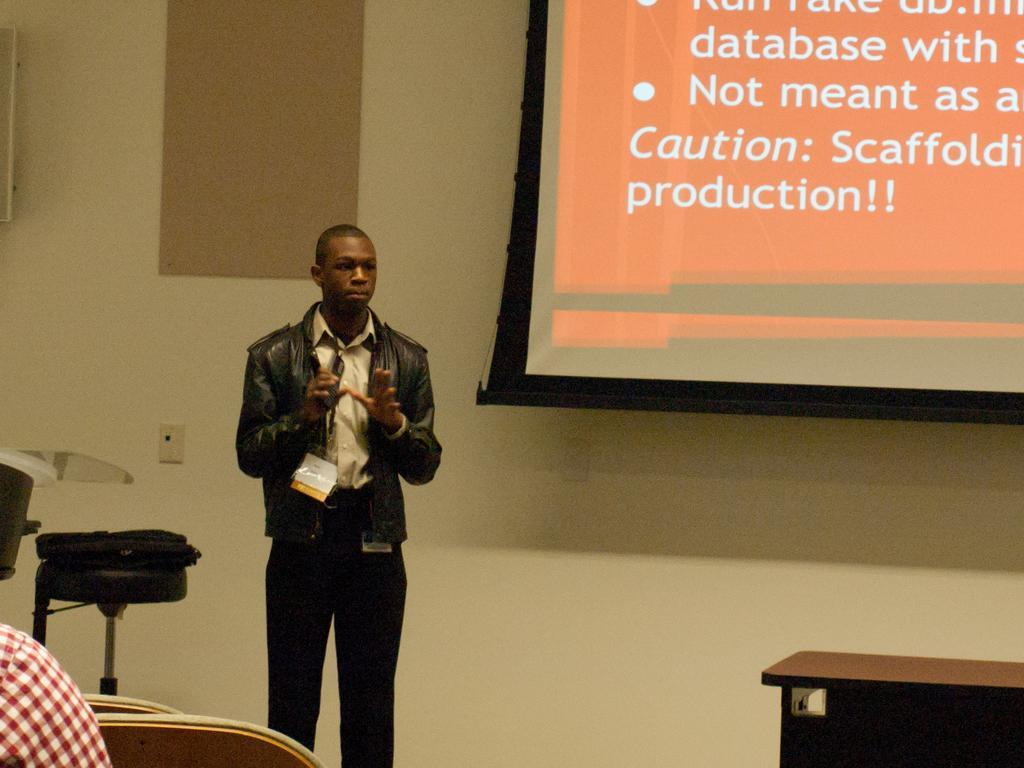Can you describe this image briefly? On the left side of the image there is a person sitting. In front of him there are two chairs. There is a person standing. Beside him there is a bag on the chair. Beside the chair there is some object. On the right side of the image there is a table. In the background of the image there is a screen. There are frames on the wall. 